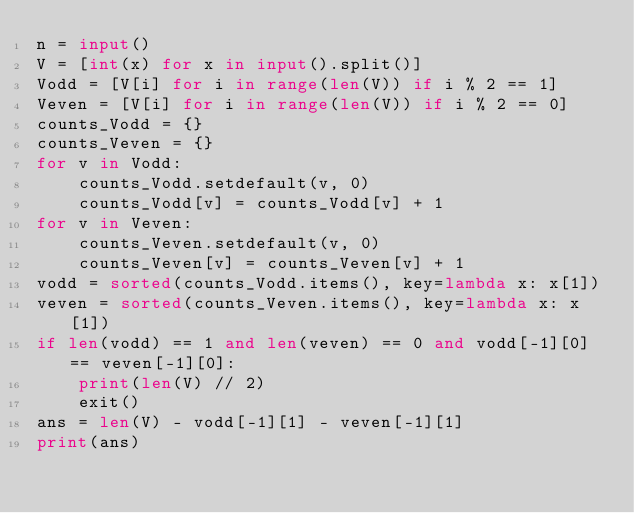<code> <loc_0><loc_0><loc_500><loc_500><_Python_>n = input()
V = [int(x) for x in input().split()]
Vodd = [V[i] for i in range(len(V)) if i % 2 == 1]
Veven = [V[i] for i in range(len(V)) if i % 2 == 0]
counts_Vodd = {}
counts_Veven = {}
for v in Vodd:
    counts_Vodd.setdefault(v, 0)
    counts_Vodd[v] = counts_Vodd[v] + 1
for v in Veven:
    counts_Veven.setdefault(v, 0)
    counts_Veven[v] = counts_Veven[v] + 1
vodd = sorted(counts_Vodd.items(), key=lambda x: x[1])
veven = sorted(counts_Veven.items(), key=lambda x: x[1])
if len(vodd) == 1 and len(veven) == 0 and vodd[-1][0] == veven[-1][0]:
    print(len(V) // 2)
    exit()
ans = len(V) - vodd[-1][1] - veven[-1][1]
print(ans)
</code> 